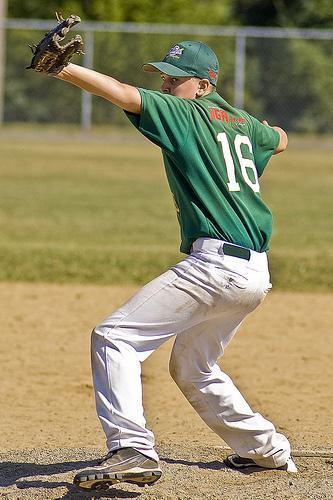How many people are in this picture?
Give a very brief answer. 1. How many different colors are on his shirt?
Give a very brief answer. 3. 